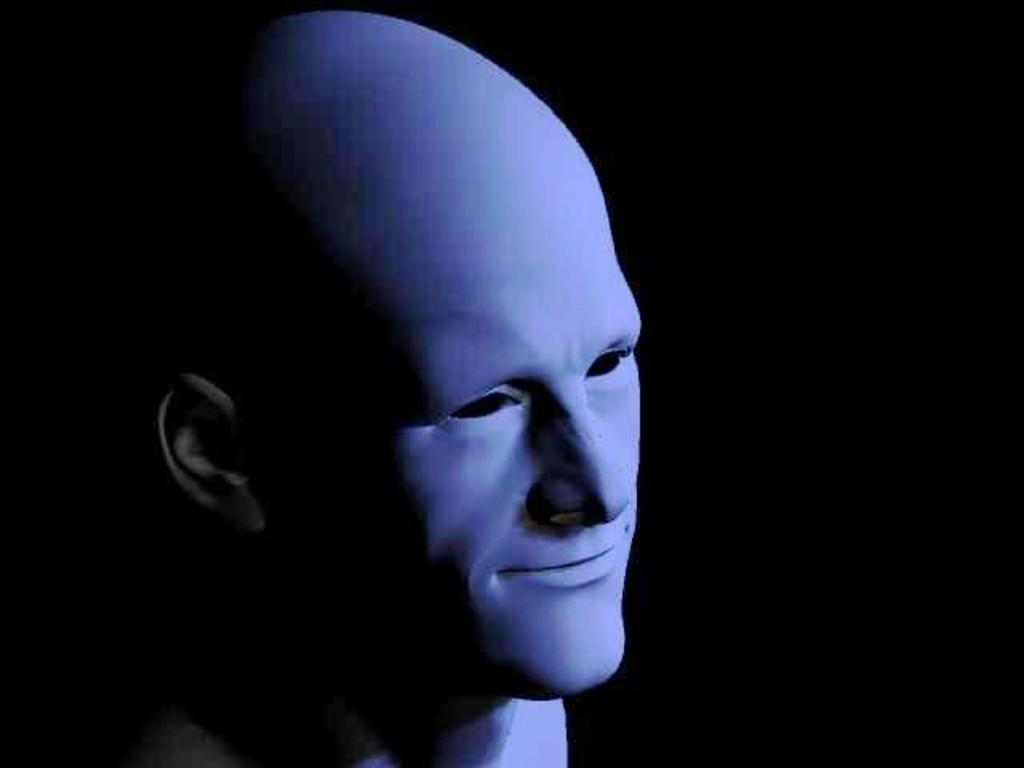What is the main subject of the image? There is a mannequin in the image. Can you describe the background of the image? The background of the image is dark. Can you see any seashore or quiver in the image? No, there is no seashore or quiver present in the image. 